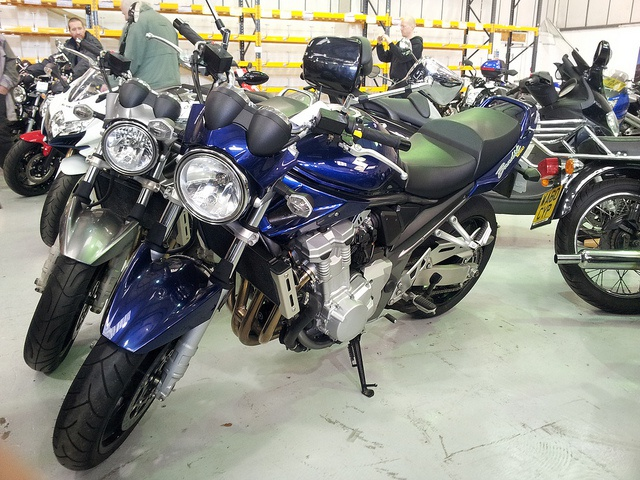Describe the objects in this image and their specific colors. I can see motorcycle in beige, black, gray, darkgray, and lightgray tones, motorcycle in beige, black, gray, darkgray, and lightgray tones, motorcycle in beige, black, gray, darkgray, and white tones, motorcycle in beige, black, white, gray, and darkgray tones, and people in beige, darkgray, gray, and lightgray tones in this image. 